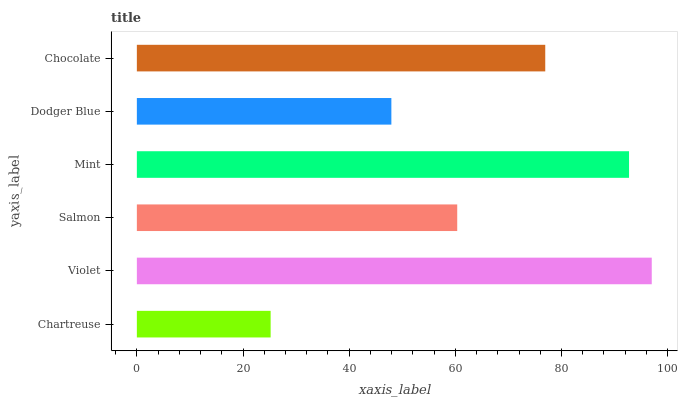Is Chartreuse the minimum?
Answer yes or no. Yes. Is Violet the maximum?
Answer yes or no. Yes. Is Salmon the minimum?
Answer yes or no. No. Is Salmon the maximum?
Answer yes or no. No. Is Violet greater than Salmon?
Answer yes or no. Yes. Is Salmon less than Violet?
Answer yes or no. Yes. Is Salmon greater than Violet?
Answer yes or no. No. Is Violet less than Salmon?
Answer yes or no. No. Is Chocolate the high median?
Answer yes or no. Yes. Is Salmon the low median?
Answer yes or no. Yes. Is Salmon the high median?
Answer yes or no. No. Is Dodger Blue the low median?
Answer yes or no. No. 